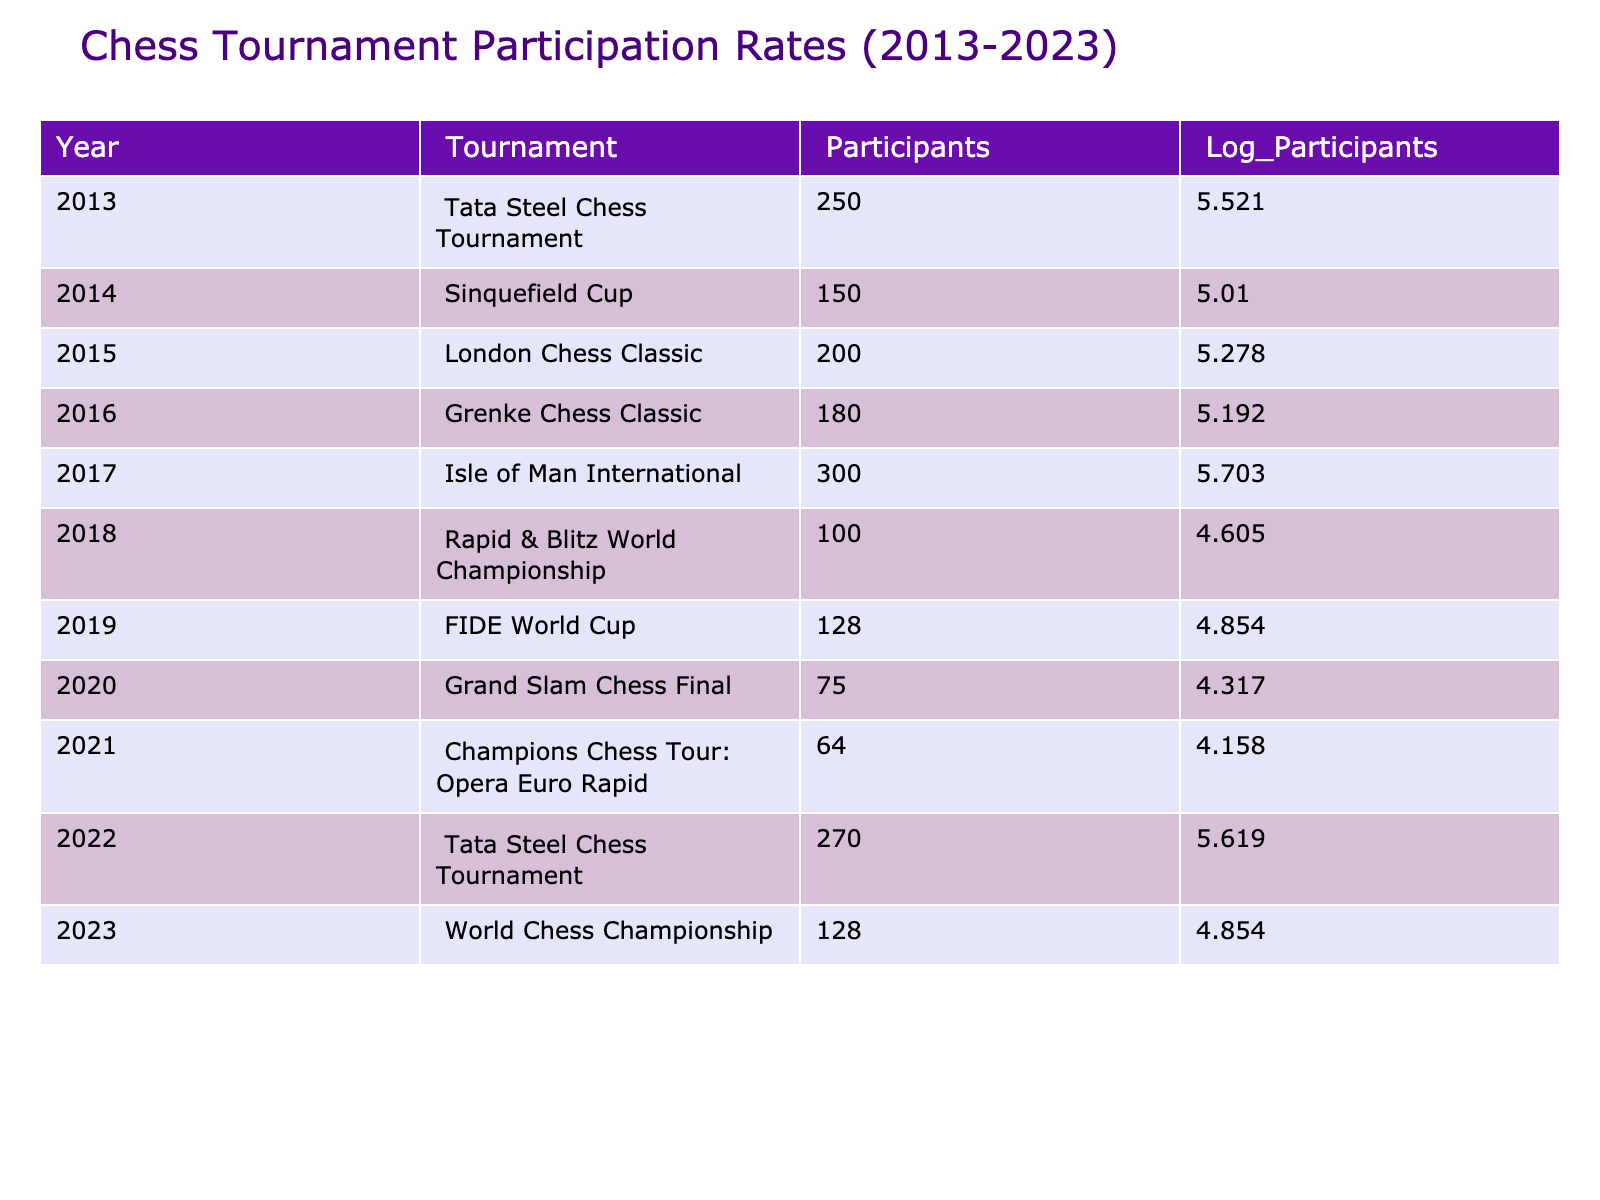What was the highest number of participants in a chess tournament over the past decade? From the table, I can see that the Isle of Man International in 2017 had the highest number of participants with 300.
Answer: 300 In which year did the Tata Steel Chess Tournament have 270 participants? The table indicates that the Tata Steel Chess Tournament had 270 participants in the year 2022.
Answer: 2022 What is the total number of participants across all tournaments listed? Summing up the participants from each tournament gives me 250 + 150 + 200 + 180 + 300 + 100 + 128 + 75 + 64 + 270 + 128 = 1875 participants in total across all tournaments.
Answer: 1875 Was there a tournament in 2020 with more than 100 participants? Looking at the table, the Grand Slam Chess Final in 2020 had only 75 participants, which is less than 100. Therefore, the answer is no.
Answer: No What was the average number of participants from 2013 to 2023? To find the average, I divide the total number of participants (1875) by the number of tournaments (11) resulting in an average of 170.45 participants.
Answer: 170.45 Did any tournament in 2021 have more participants than the tournament in 2014? The Sinquefield Cup in 2014 had 150 participants, while the Champions Chess Tour in 2021 had fewer, only 64 participants. This means that no.
Answer: No Which tournament had the least number of participants, and what was the number? The table shows that the Grand Slam Chess Final in 2020 had the least number of participants with a total of 75.
Answer: 75 Is it true that the participation in the Tata Steel Chess Tournament increased from 2013 to 2022? In 2013, the Tata Steel Chess Tournament had 250 participants, and in 2022 it increased to 270 participants, which confirms the statement is true.
Answer: Yes 